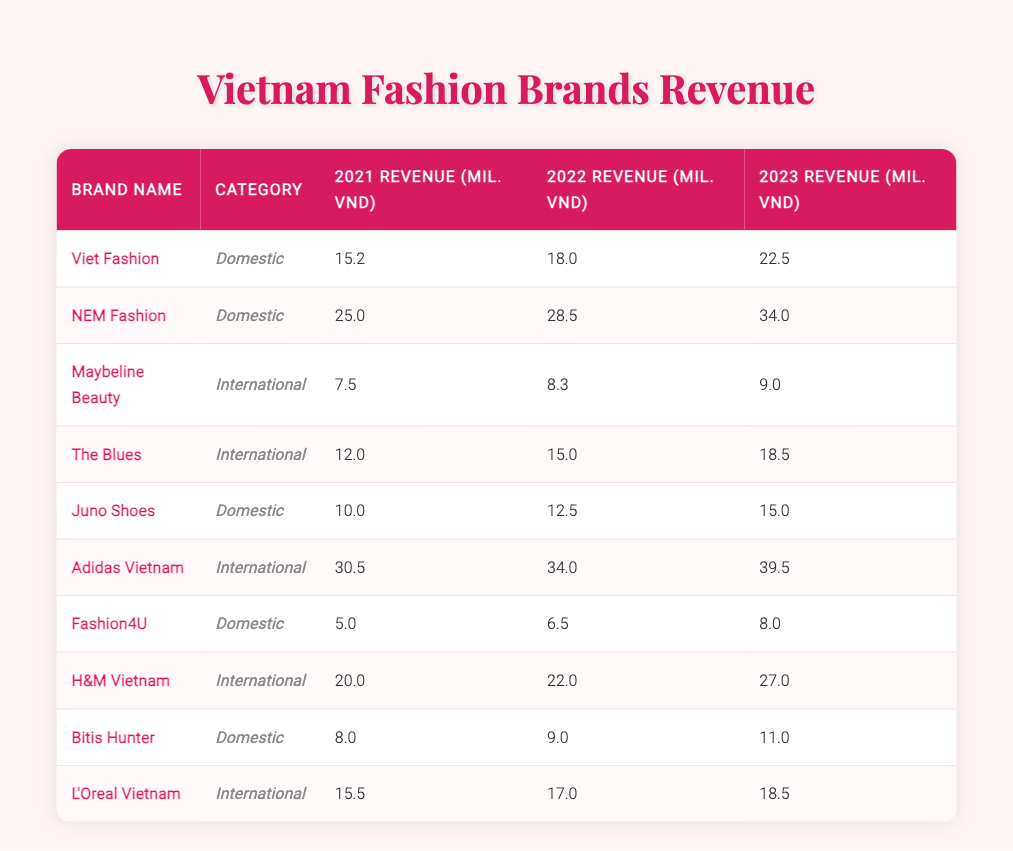What was the revenue of NEM Fashion in 2023? By looking at the row for NEM Fashion, the value in the 2023 revenue column is 34.0 million VND.
Answer: 34.0 What is the revenue difference for H&M Vietnam from 2021 to 2023? The revenue for H&M Vietnam in 2021 was 20.0 million VND, and in 2023 it was 27.0 million VND. The difference is 27.0 - 20.0 = 7.0 million VND.
Answer: 7.0 Is Juno Shoes' revenue in 2022 higher than 13 million VND? The revenue for Juno Shoes in 2022 was 12.5 million VND, which is less than 13 million VND. Therefore, the answer is no.
Answer: No What is the total revenue of all domestic brands in 2023? The domestic brands and their 2023 revenues are: Viet Fashion (22.5), NEM Fashion (34.0), Juno Shoes (15.0), Fashion4U (8.0), and Bitis Hunter (11.0). Adding these gives: 22.5 + 34.0 + 15.0 + 8.0 + 11.0 = 90.5 million VND.
Answer: 90.5 Did all international brands see an increase in revenue from 2021 to 2023? The international brands are Maybeline Beauty, The Blues, Adidas Vietnam, H&M Vietnam, and L'Oreal Vietnam. Analyzing their revenues shows: Maybeline Beauty (7.5 to 9.0), The Blues (12.0 to 18.5), Adidas Vietnam (30.5 to 39.5), H&M Vietnam (20.0 to 27.0), and L'Oreal Vietnam (15.5 to 18.5). All of them have increased revenue from 2021 to 2023. Therefore, the statement is true.
Answer: Yes Which brand had the highest revenue in 2022? Looking at the 2022 revenue column, we compare the revenues of all brands. NEM Fashion has the highest revenue at 28.5 million VND.
Answer: NEM Fashion What is the average revenue of international brands in 2023? The international brands in 2023 and their revenues are: Maybeline Beauty (9.0), The Blues (18.5), Adidas Vietnam (39.5), H&M Vietnam (27.0), and L'Oreal Vietnam (18.5). Summing these gives 9.0 + 18.5 + 39.5 + 27.0 + 18.5 = 112.5 million VND. There are 5 brands, so the average is 112.5 / 5 = 22.5 million VND.
Answer: 22.5 Has the revenue of Fashion4U increased every year? The revenue for Fashion4U is 5.0 million VND in 2021, 6.5 million VND in 2022, and 8.0 million VND in 2023. Since each year shows an increase, the statement is true.
Answer: Yes 